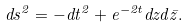<formula> <loc_0><loc_0><loc_500><loc_500>d s ^ { 2 } = - d t ^ { 2 } + e ^ { - 2 t } d z d \bar { z } .</formula> 